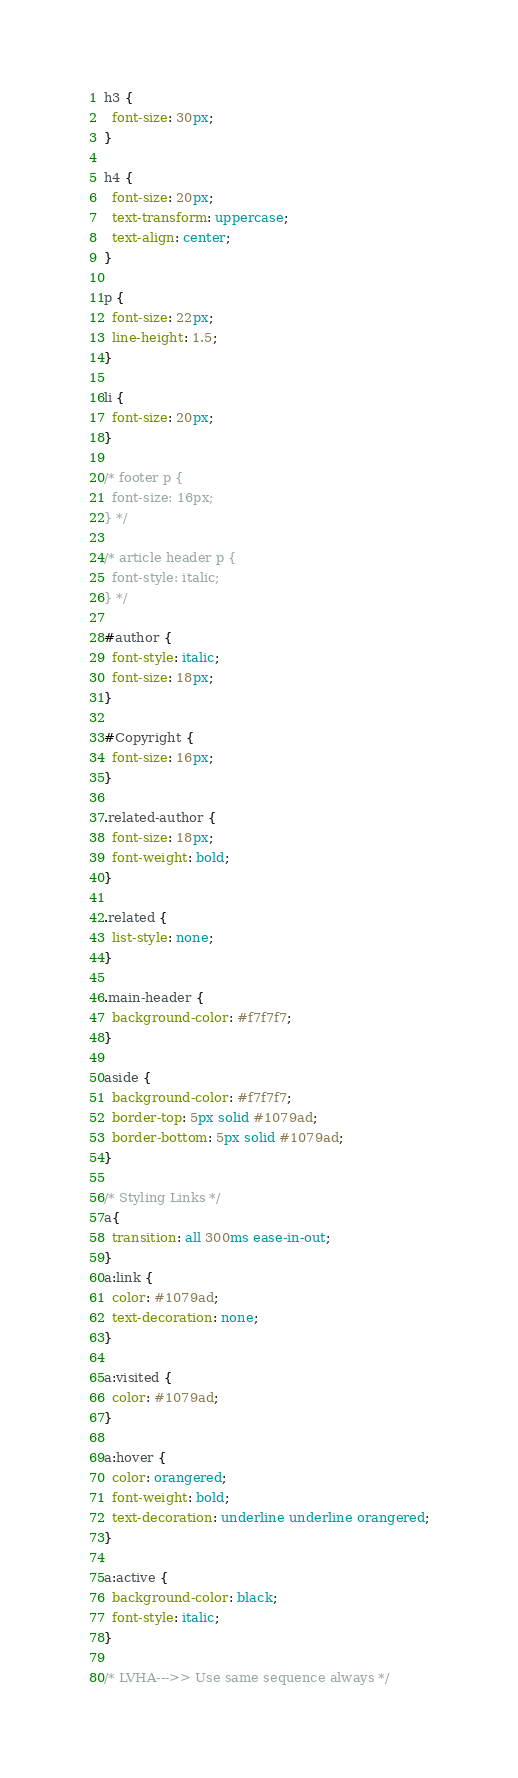Convert code to text. <code><loc_0><loc_0><loc_500><loc_500><_CSS_>h3 {
  font-size: 30px;
}

h4 {
  font-size: 20px;
  text-transform: uppercase;
  text-align: center;
}

p {
  font-size: 22px;
  line-height: 1.5;
}

li {
  font-size: 20px;
}

/* footer p {
  font-size: 16px;
} */

/* article header p {
  font-style: italic;
} */

#author {
  font-style: italic;
  font-size: 18px;
}

#Copyright {
  font-size: 16px;
}

.related-author {
  font-size: 18px;
  font-weight: bold;
}

.related {
  list-style: none;
}

.main-header {
  background-color: #f7f7f7;
}

aside {
  background-color: #f7f7f7;
  border-top: 5px solid #1079ad;
  border-bottom: 5px solid #1079ad;
}

/* Styling Links */
a{
  transition: all 300ms ease-in-out;
}
a:link {
  color: #1079ad;
  text-decoration: none;
}

a:visited {
  color: #1079ad;
}

a:hover {
  color: orangered;
  font-weight: bold;
  text-decoration: underline underline orangered;
}

a:active {
  background-color: black;
  font-style: italic;
}

/* LVHA--->> Use same sequence always */
</code> 